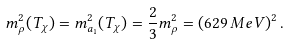Convert formula to latex. <formula><loc_0><loc_0><loc_500><loc_500>m ^ { 2 } _ { \rho } ( T _ { \chi } ) = m ^ { 2 } _ { a _ { 1 } } ( T _ { \chi } ) = \frac { 2 } { 3 } m _ { \rho } ^ { 2 } = ( 6 2 9 \, M e V ) ^ { 2 } \, .</formula> 